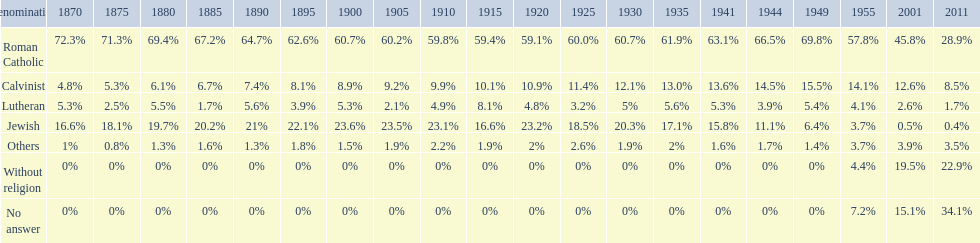What is the largest religious denomination in budapest? Roman Catholic. 